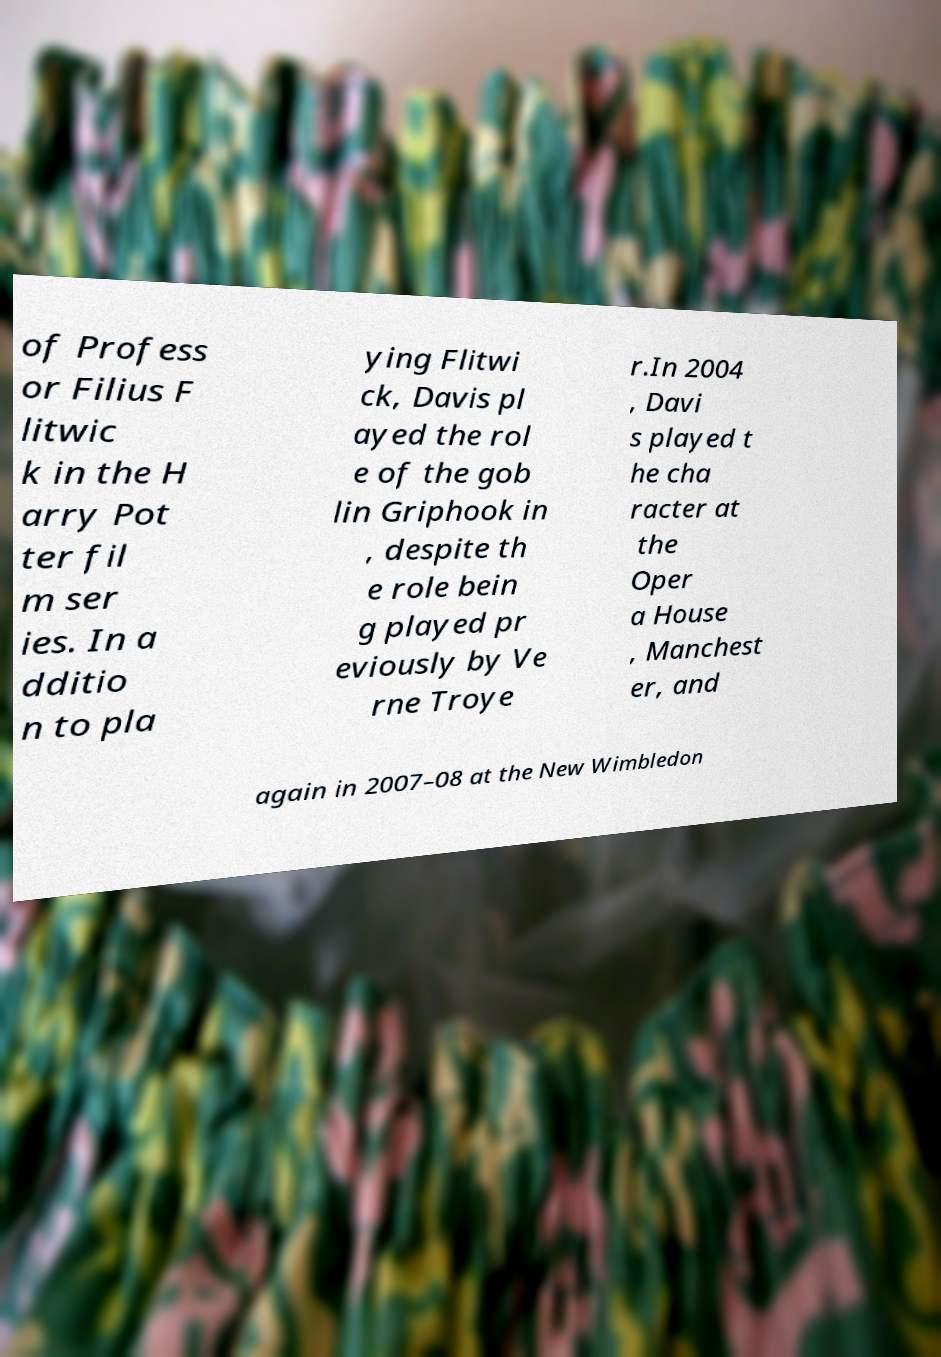Can you accurately transcribe the text from the provided image for me? of Profess or Filius F litwic k in the H arry Pot ter fil m ser ies. In a dditio n to pla ying Flitwi ck, Davis pl ayed the rol e of the gob lin Griphook in , despite th e role bein g played pr eviously by Ve rne Troye r.In 2004 , Davi s played t he cha racter at the Oper a House , Manchest er, and again in 2007–08 at the New Wimbledon 